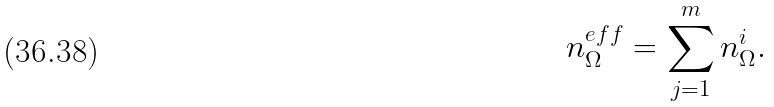<formula> <loc_0><loc_0><loc_500><loc_500>n _ { \Omega } ^ { e f f } = \sum _ { j = 1 } ^ { m } n _ { \Omega } ^ { i } .</formula> 